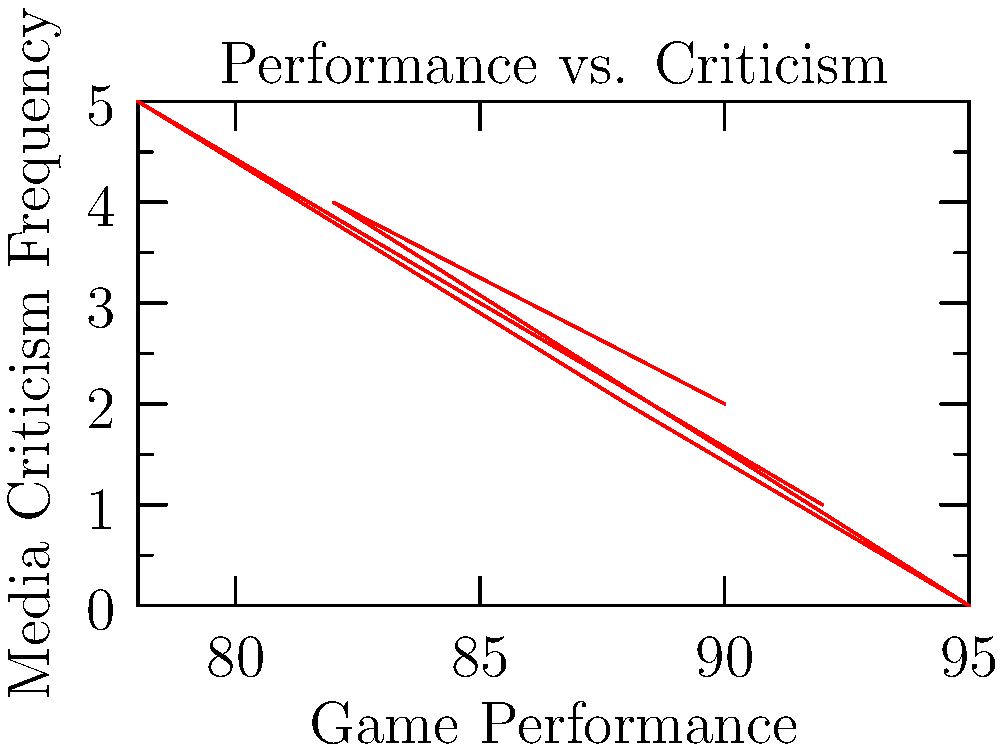Based on the dual-axis chart showing your game performance and media criticism frequency, what appears to be the general relationship between these two variables? To determine the relationship between game performance and media criticism frequency, we need to analyze the trend in the graph:

1. Observe the overall pattern: As game performance increases (moves right on the x-axis), media criticism frequency tends to decrease (moves down on the y-axis).

2. Look at specific data points:
   - When performance is highest (95), criticism is at its lowest (0).
   - When performance is lowest (78), criticism is at its highest (5).

3. Consider the pattern's consistency: There's a general downward trend from left to right, though it's not perfectly linear.

4. Interpret the relationship: This suggests an inverse or negative correlation between game performance and media criticism frequency.

5. Understand the implications: Better game performance tends to result in less media criticism, while poorer performance tends to attract more criticism.
Answer: Inverse correlation 